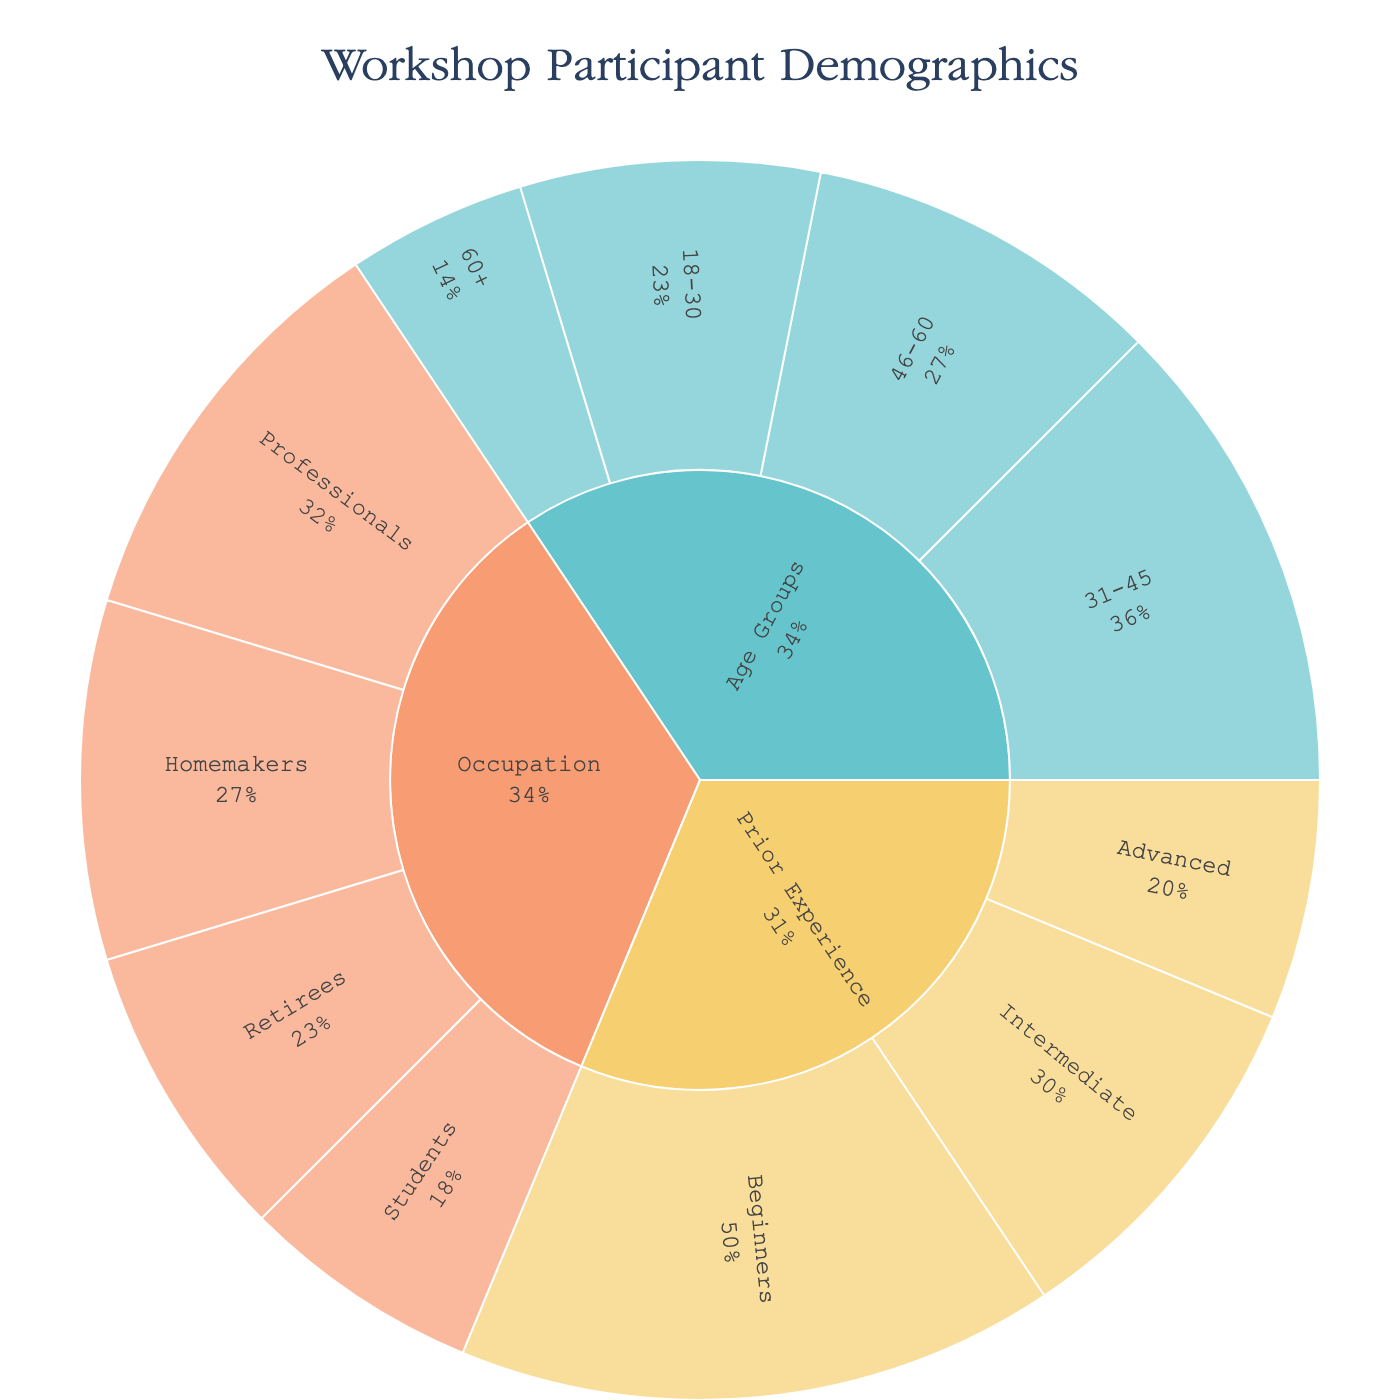What's the title of the sunburst plot? The title is usually placed at the top center of the plot. By observing the plot, we can see the title clearly.
Answer: Workshop Participant Demographics Which age group has the largest number of participants? The sunburst plot shows segments proportional to the values they represent. By locating the "Age Groups" category and observing the size of slices, the largest slice represents the age group with the most participants.
Answer: 31-45 How many professionals participated in the workshop? Navigate to the segment labeled "Professionals" under the "Occupation" category. The value presented via hover or the percentage size helps identify the number of participants.
Answer: 35 What is the total number of participants across all age groups? By summing up the value of each age group: 18-30 (25), 31-45 (40), 46-60 (30), and 60+ (15), the total can be computed. 25 + 40 + 30 + 15 = 110
Answer: 110 What percentage of total participants are beginners in terms of prior experience? First, identify the total number of participants by adding all values, which is 50 (Beginners) + 30 (Intermediate) + 20 (Advanced) = 100. The percentage of beginners is (50/100) * 100%.
Answer: 50% Which occupation category has fewer participants: Students or Homemakers? Compare the sizes of the segments for "Students" and "Homemakers" under the "Occupation" category. The "Students" segment represents 20, whereas "Homemakers" represents 30. Hence, students have fewer participants.
Answer: Students Within the age group "18-30", what is the proportion compared to the total number of workshop participants? Calculate the total number of participants in all categories, which is 275. For the 18-30 group, the proportion is (25/275) * 100%.
Answer: 9.1% How do the number of retirees compare with the number of advanced participants in terms of prior experience? Locate "Retirees" under "Occupation" and "Advanced" under "Prior Experience". Retirees have 25 participants, while Advanced has 20 participants.
Answer: Retirees have more participants What is the combined number of participants who are either Homemakers or Retirees? Add the number of Homemakers (30) and Retirees (25) together: 30 + 25 = 55.
Answer: 55 Which category shows the greatest variability in participant values? By examining the variation in the size of the segments for each main category (Age Groups, Occupation, Prior Experience), the "Age Groups" category spans from 15 to 40, "Occupation" from 20 to 35, and "Prior Experience" from 20 to 50. Thus, "Prior Experience" shows the greatest range.
Answer: Prior Experience 